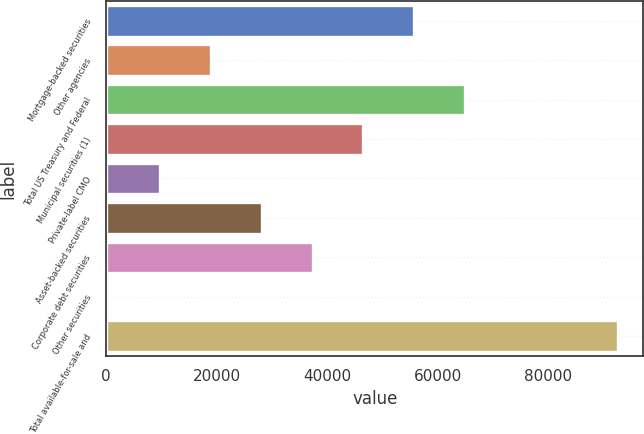Convert chart to OTSL. <chart><loc_0><loc_0><loc_500><loc_500><bar_chart><fcel>Mortgage-backed securities<fcel>Other agencies<fcel>Total US Treasury and Federal<fcel>Municipal securities (1)<fcel>Private-label CMO<fcel>Asset-backed securities<fcel>Corporate debt securities<fcel>Other securities<fcel>Total available-for-sale and<nl><fcel>55729.6<fcel>18917.2<fcel>64932.7<fcel>46526.5<fcel>9714.1<fcel>28120.3<fcel>37323.4<fcel>511<fcel>92542<nl></chart> 